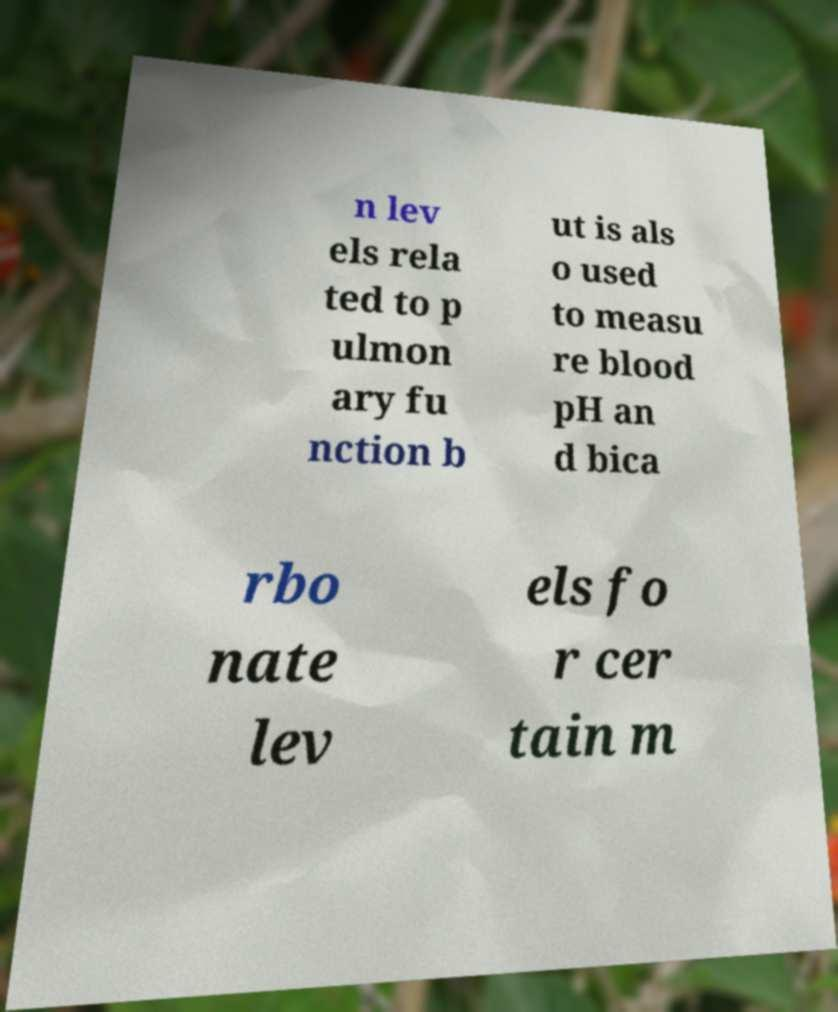What messages or text are displayed in this image? I need them in a readable, typed format. n lev els rela ted to p ulmon ary fu nction b ut is als o used to measu re blood pH an d bica rbo nate lev els fo r cer tain m 